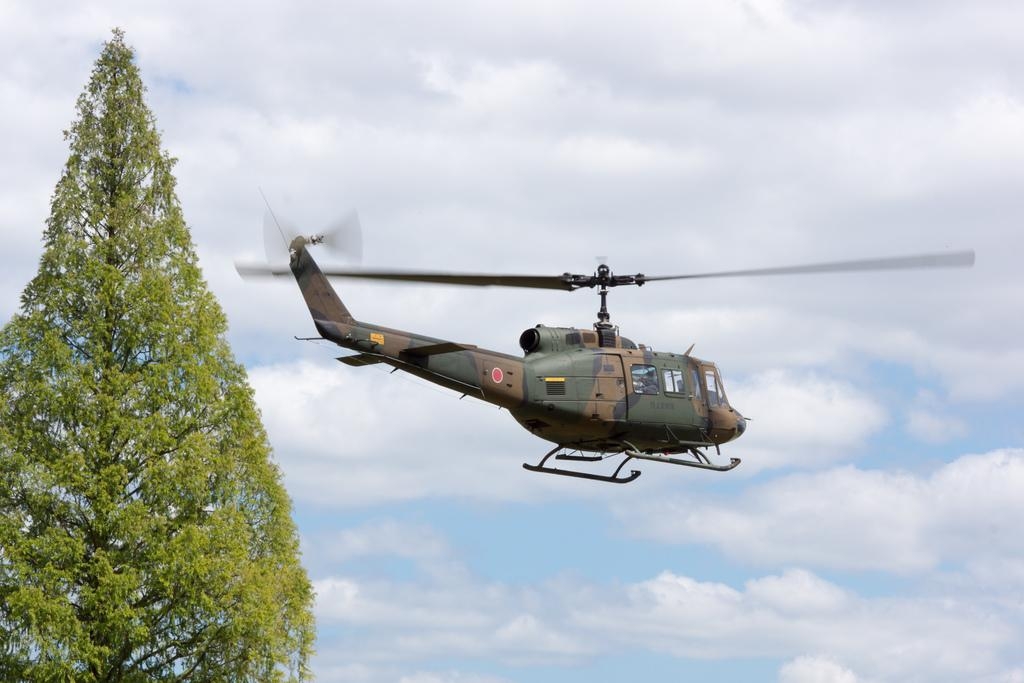What is located on the left side of the image? There is a tree on the left side of the image. What can be seen in the air in the image? There is a helicopter in the air in the image. What is visible in the background of the image? There is a sky visible in the background of the image. What can be observed in the sky? Clouds are present in the sky. What type of bell can be heard ringing in the image? There is no bell present in the image, and therefore no sound can be heard. What message of peace is conveyed in the image? The image does not convey a specific message of peace; it features a tree, a helicopter, and clouds in the sky. 